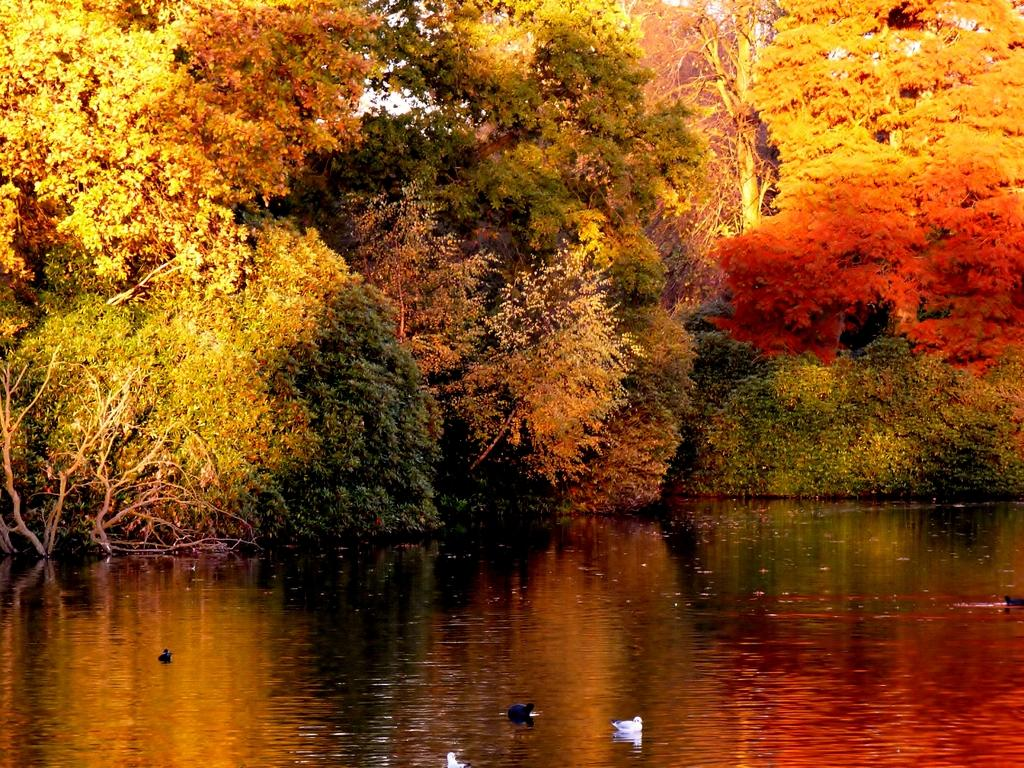What type of animals are on the water in the image? There are ducks on the surface of the water in the image. What can be seen in the background of the image? There are trees in the background of the image. What type of marble is used to build the amusement park in the image? There is no amusement park or marble present in the image; it features ducks on the water and trees in the background. 